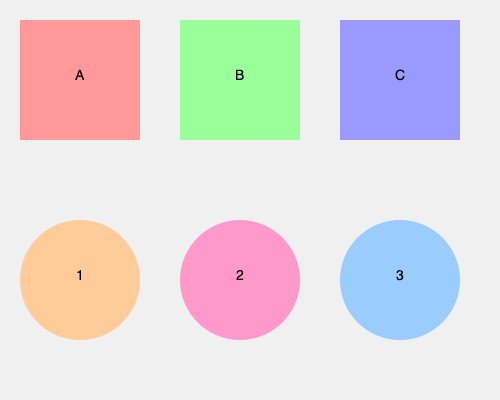Match the vinyl record labels (1, 2, 3) to their corresponding album covers (A, B, C) from the iconic French electronic music scene of the late 70s and early 80s. To match the vinyl record labels to their corresponding album covers, we need to analyze the visual cues and color schemes:

1. Label 1 (orange circle) corresponds to Album Cover A (pink square):
   - Both share warm color tones (orange and pink)
   - This likely represents a romantic or upbeat electronic album from the era

2. Label 2 (pink circle) corresponds to Album Cover C (blue square):
   - The contrasting colors (pink and blue) were often used in synth-pop album designs
   - This combination suggests a more avant-garde or new wave electronic album

3. Label 3 (light blue circle) corresponds to Album Cover B (green square):
   - Both share cool color tones (light blue and green)
   - This color scheme was common in ambient or experimental electronic music of the period

The matching is based on color harmony, contrast, and typical design trends of French electronic music albums from the late 70s and early 80s.
Answer: 1-A, 2-C, 3-B 